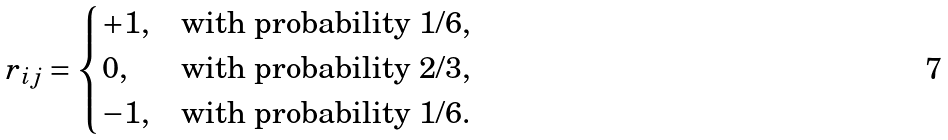<formula> <loc_0><loc_0><loc_500><loc_500>r _ { i j } = \begin{dcases} + 1 , & \text {with probability $1/6$} , \\ 0 , & \text {with probability $2/3$} , \\ - 1 , & \text {with probability $1/6$.} \end{dcases}</formula> 